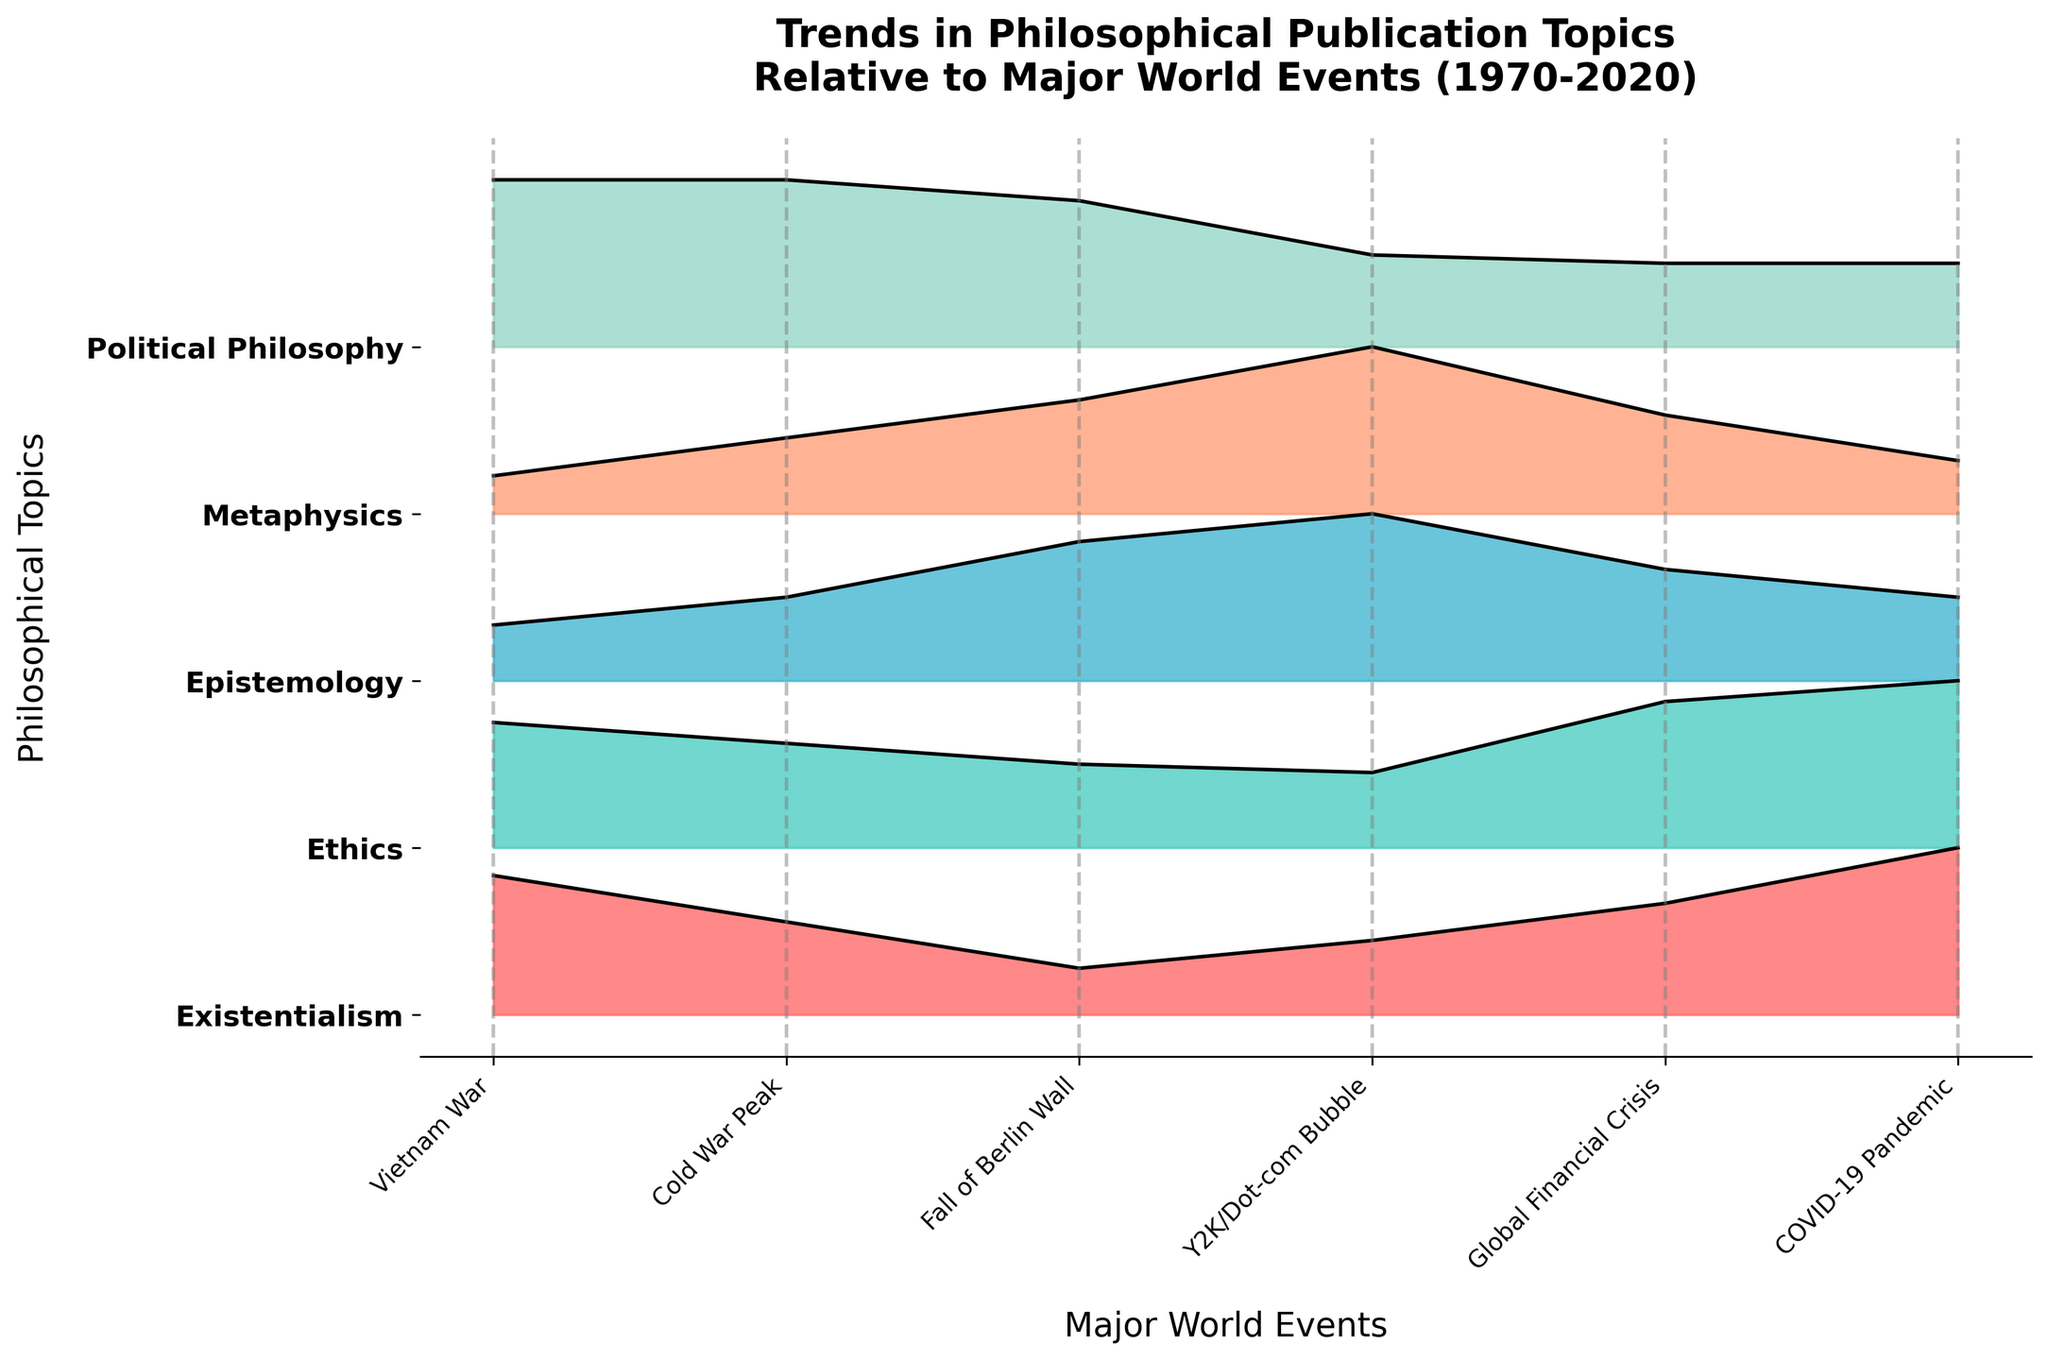What is the title of the figure? The title is usually located at the top of the figure. In this case, it reads "Trends in Philosophical Publication Topics Relative to Major World Events (1970-2020)."
Answer: Trends in Philosophical Publication Topics Relative to Major World Events (1970-2020) Which philosophical topic shows the highest value during the Vietnam War? To find this, observe the section for the year linked to the Vietnam War. The highest peak in the Ridgeline plot (during 1970) corresponds to Political Philosophy.
Answer: Political Philosophy How did the interest in Existentialism change from the Cold War Peak to the Global Financial Crisis? Examine the plots for the years 1980 and 2010. Existentialism shows a value of 10 in 1980 and rises to 12 by 2010. This indicates an increase.
Answer: Increased Which philosophical topic had the most significant decrease in publication interest between the Y2K/Dot-com Bubble and the Global Financial Crisis? Comparing values for the years 2000 and 2010, Metaphysics drops from 22 to 13. This decline of 9 is the largest among the given topics.
Answer: Metaphysics During which event does Ethics have its maximum value, and what is that value? Identify the peak related to Ethics across multiple events. Ethics reaches its highest at the COVID-19 Pandemic event with a value of 40.
Answer: COVID-19 Pandemic, 40 What is the cumulative trend of Political Philosophy over the entire period? Summing the values for Political Philosophy from 1970 to 2020 (40 + 40 + 35 + 22 + 20 + 20) results in a total of 177.
Answer: 177 How did interest in Epistemology change from the Cold War Peak to the Fall of the Berlin Wall? To determine this, check Epistemology for 1980 (15) and 1990 (25). It shows a rise by 10.
Answer: Increased by 10 Which year did Metaphysics have its second-lowest value, and what major world event does it correspond to? By analyzing the values, Metaphysics in 2020 is the second-lowest with a value of 7. This year corresponds to the COVID-19 Pandemic.
Answer: 2020, COVID-19 Pandemic How does the value of Ethics in 1970 compare to its value in 2020? Observe Ethics for 1970 (30) and 2020 (40). It shows an increase by 10 over this period.
Answer: Increased by 10 